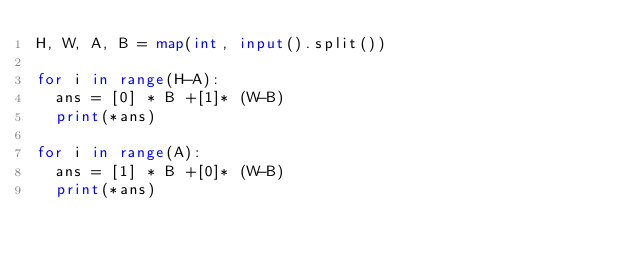Convert code to text. <code><loc_0><loc_0><loc_500><loc_500><_Python_>H, W, A, B = map(int, input().split())

for i in range(H-A):
  ans = [0] * B +[1]* (W-B)
  print(*ans)
  
for i in range(A):
  ans = [1] * B +[0]* (W-B)
  print(*ans)</code> 